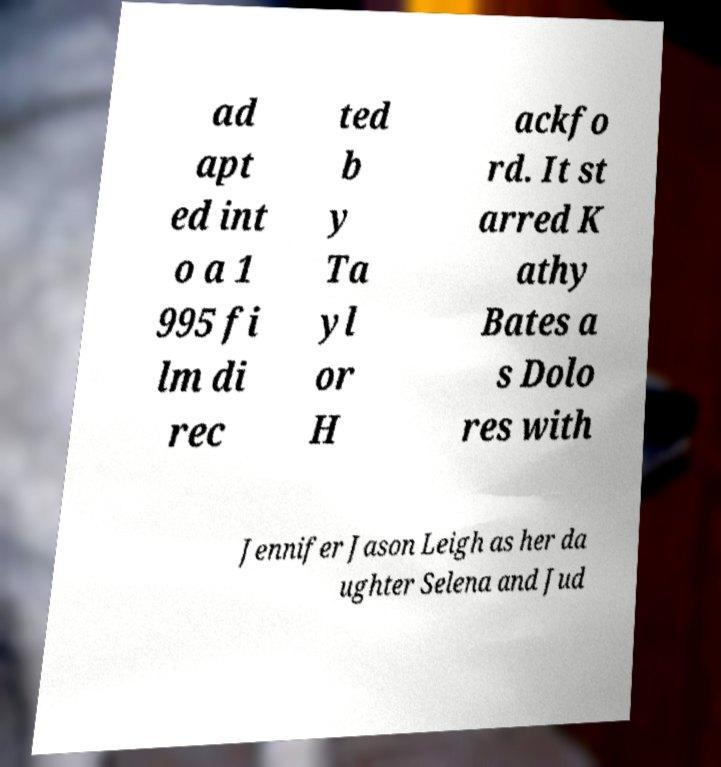Could you assist in decoding the text presented in this image and type it out clearly? ad apt ed int o a 1 995 fi lm di rec ted b y Ta yl or H ackfo rd. It st arred K athy Bates a s Dolo res with Jennifer Jason Leigh as her da ughter Selena and Jud 